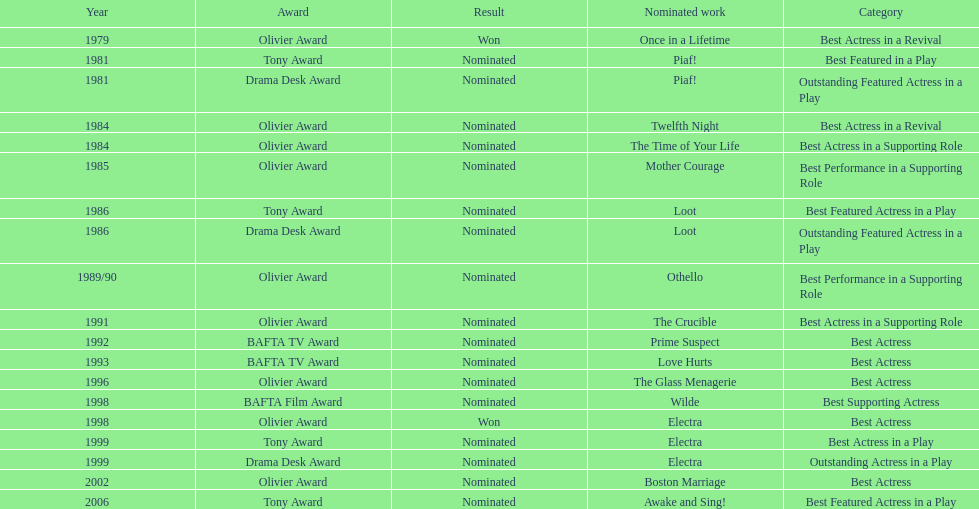What play was wanamaker nominated for best featured in a play in 1981? Piaf!. 